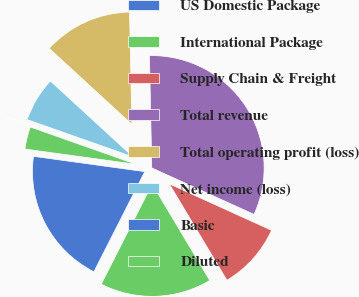<chart> <loc_0><loc_0><loc_500><loc_500><pie_chart><fcel>US Domestic Package<fcel>International Package<fcel>Supply Chain & Freight<fcel>Total revenue<fcel>Total operating profit (loss)<fcel>Net income (loss)<fcel>Basic<fcel>Diluted<nl><fcel>19.69%<fcel>16.06%<fcel>9.64%<fcel>32.12%<fcel>12.85%<fcel>6.43%<fcel>0.0%<fcel>3.22%<nl></chart> 